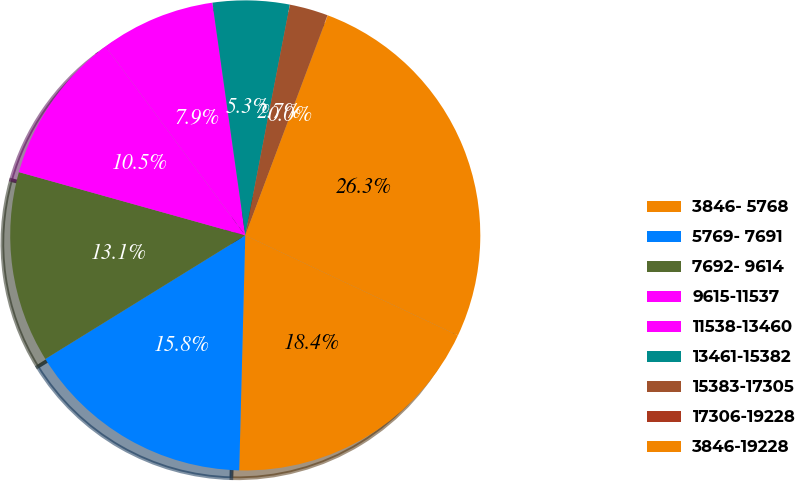Convert chart to OTSL. <chart><loc_0><loc_0><loc_500><loc_500><pie_chart><fcel>3846- 5768<fcel>5769- 7691<fcel>7692- 9614<fcel>9615-11537<fcel>11538-13460<fcel>13461-15382<fcel>15383-17305<fcel>17306-19228<fcel>3846-19228<nl><fcel>18.41%<fcel>15.78%<fcel>13.15%<fcel>10.53%<fcel>7.9%<fcel>5.27%<fcel>2.65%<fcel>0.02%<fcel>26.29%<nl></chart> 